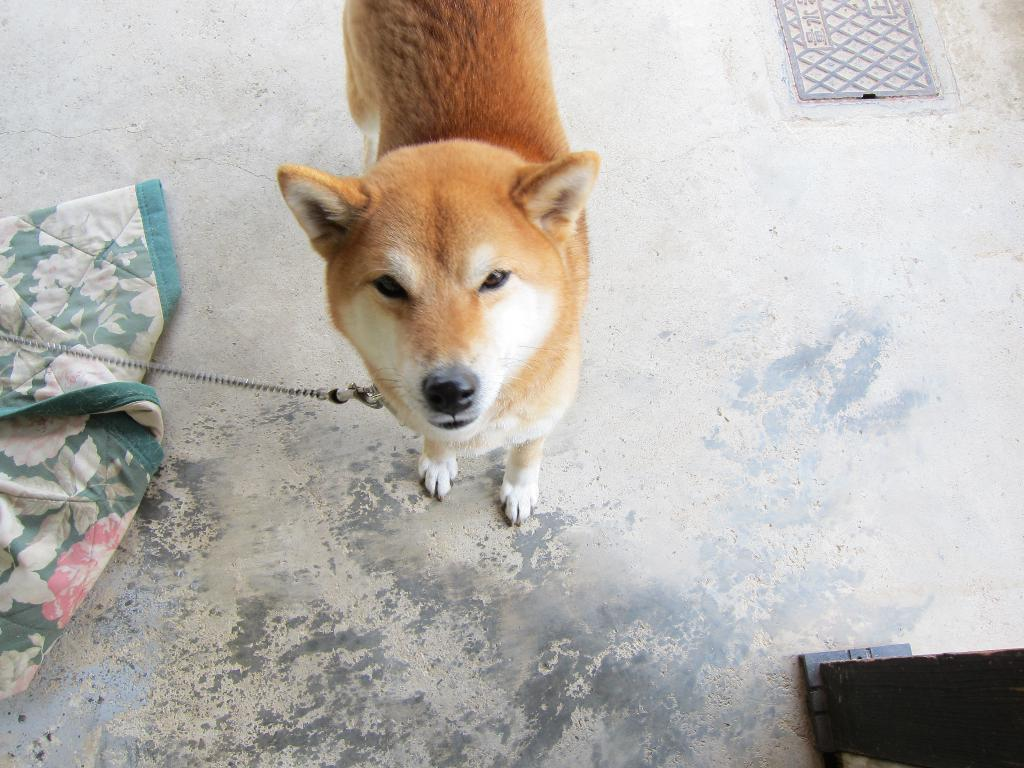What type of animal is in the image? There is a golden dog in the image. Where is the dog located in the image? The dog is standing in the middle of the image. What is the dog tied to in the image? The dog is tied to a chain. What can be seen on the left side of the image? There is a carpet on the left side of the image. What is visible in the top right side of the image? There is a manhole visible in the top right side of the image. What type of soup is being prepared in the image? There is no soup present in the image; it features a golden dog standing in the middle of the image. 